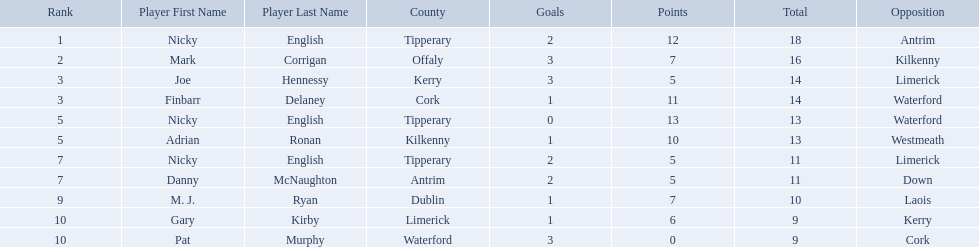What numbers are in the total column? 18, 16, 14, 14, 13, 13, 11, 11, 10, 9, 9. What row has the number 10 in the total column? 9, M. J. Ryan, Dublin, 1-7, 10, Laois. What name is in the player column for this row? M. J. Ryan. 